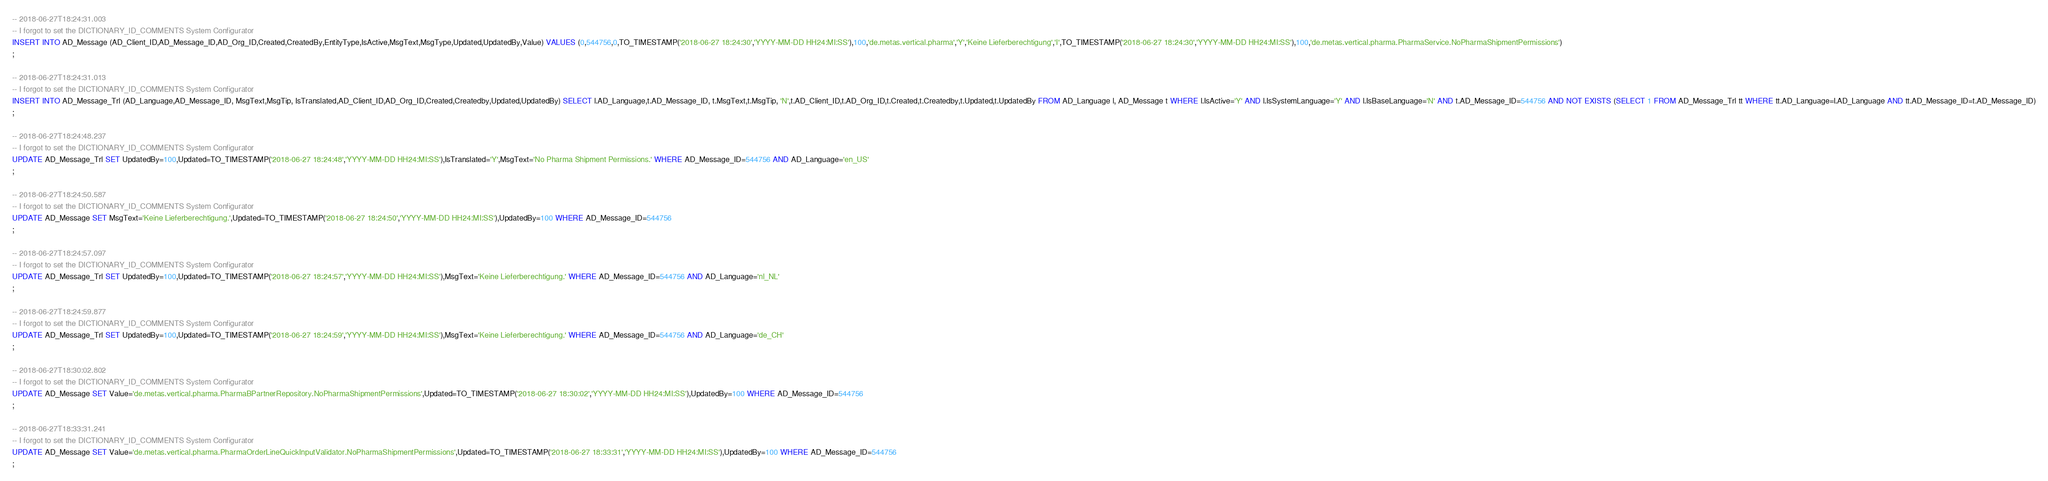Convert code to text. <code><loc_0><loc_0><loc_500><loc_500><_SQL_>-- 2018-06-27T18:24:31.003
-- I forgot to set the DICTIONARY_ID_COMMENTS System Configurator
INSERT INTO AD_Message (AD_Client_ID,AD_Message_ID,AD_Org_ID,Created,CreatedBy,EntityType,IsActive,MsgText,MsgType,Updated,UpdatedBy,Value) VALUES (0,544756,0,TO_TIMESTAMP('2018-06-27 18:24:30','YYYY-MM-DD HH24:MI:SS'),100,'de.metas.vertical.pharma','Y','Keine Lieferberechtigung','I',TO_TIMESTAMP('2018-06-27 18:24:30','YYYY-MM-DD HH24:MI:SS'),100,'de.metas.vertical.pharma.PharmaService.NoPharmaShipmentPermissions')
;

-- 2018-06-27T18:24:31.013
-- I forgot to set the DICTIONARY_ID_COMMENTS System Configurator
INSERT INTO AD_Message_Trl (AD_Language,AD_Message_ID, MsgText,MsgTip, IsTranslated,AD_Client_ID,AD_Org_ID,Created,Createdby,Updated,UpdatedBy) SELECT l.AD_Language,t.AD_Message_ID, t.MsgText,t.MsgTip, 'N',t.AD_Client_ID,t.AD_Org_ID,t.Created,t.Createdby,t.Updated,t.UpdatedBy FROM AD_Language l, AD_Message t WHERE l.IsActive='Y' AND l.IsSystemLanguage='Y' AND l.IsBaseLanguage='N' AND t.AD_Message_ID=544756 AND NOT EXISTS (SELECT 1 FROM AD_Message_Trl tt WHERE tt.AD_Language=l.AD_Language AND tt.AD_Message_ID=t.AD_Message_ID)
;

-- 2018-06-27T18:24:48.237
-- I forgot to set the DICTIONARY_ID_COMMENTS System Configurator
UPDATE AD_Message_Trl SET UpdatedBy=100,Updated=TO_TIMESTAMP('2018-06-27 18:24:48','YYYY-MM-DD HH24:MI:SS'),IsTranslated='Y',MsgText='No Pharma Shipment Permissions.' WHERE AD_Message_ID=544756 AND AD_Language='en_US'
;

-- 2018-06-27T18:24:50.587
-- I forgot to set the DICTIONARY_ID_COMMENTS System Configurator
UPDATE AD_Message SET MsgText='Keine Lieferberechtigung.',Updated=TO_TIMESTAMP('2018-06-27 18:24:50','YYYY-MM-DD HH24:MI:SS'),UpdatedBy=100 WHERE AD_Message_ID=544756
;

-- 2018-06-27T18:24:57.097
-- I forgot to set the DICTIONARY_ID_COMMENTS System Configurator
UPDATE AD_Message_Trl SET UpdatedBy=100,Updated=TO_TIMESTAMP('2018-06-27 18:24:57','YYYY-MM-DD HH24:MI:SS'),MsgText='Keine Lieferberechtigung.' WHERE AD_Message_ID=544756 AND AD_Language='nl_NL'
;

-- 2018-06-27T18:24:59.877
-- I forgot to set the DICTIONARY_ID_COMMENTS System Configurator
UPDATE AD_Message_Trl SET UpdatedBy=100,Updated=TO_TIMESTAMP('2018-06-27 18:24:59','YYYY-MM-DD HH24:MI:SS'),MsgText='Keine Lieferberechtigung.' WHERE AD_Message_ID=544756 AND AD_Language='de_CH'
;

-- 2018-06-27T18:30:02.802
-- I forgot to set the DICTIONARY_ID_COMMENTS System Configurator
UPDATE AD_Message SET Value='de.metas.vertical.pharma.PharmaBPartnerRepository.NoPharmaShipmentPermissions',Updated=TO_TIMESTAMP('2018-06-27 18:30:02','YYYY-MM-DD HH24:MI:SS'),UpdatedBy=100 WHERE AD_Message_ID=544756
;

-- 2018-06-27T18:33:31.241
-- I forgot to set the DICTIONARY_ID_COMMENTS System Configurator
UPDATE AD_Message SET Value='de.metas.vertical.pharma.PharmaOrderLineQuickInputValidator.NoPharmaShipmentPermissions',Updated=TO_TIMESTAMP('2018-06-27 18:33:31','YYYY-MM-DD HH24:MI:SS'),UpdatedBy=100 WHERE AD_Message_ID=544756
;

</code> 